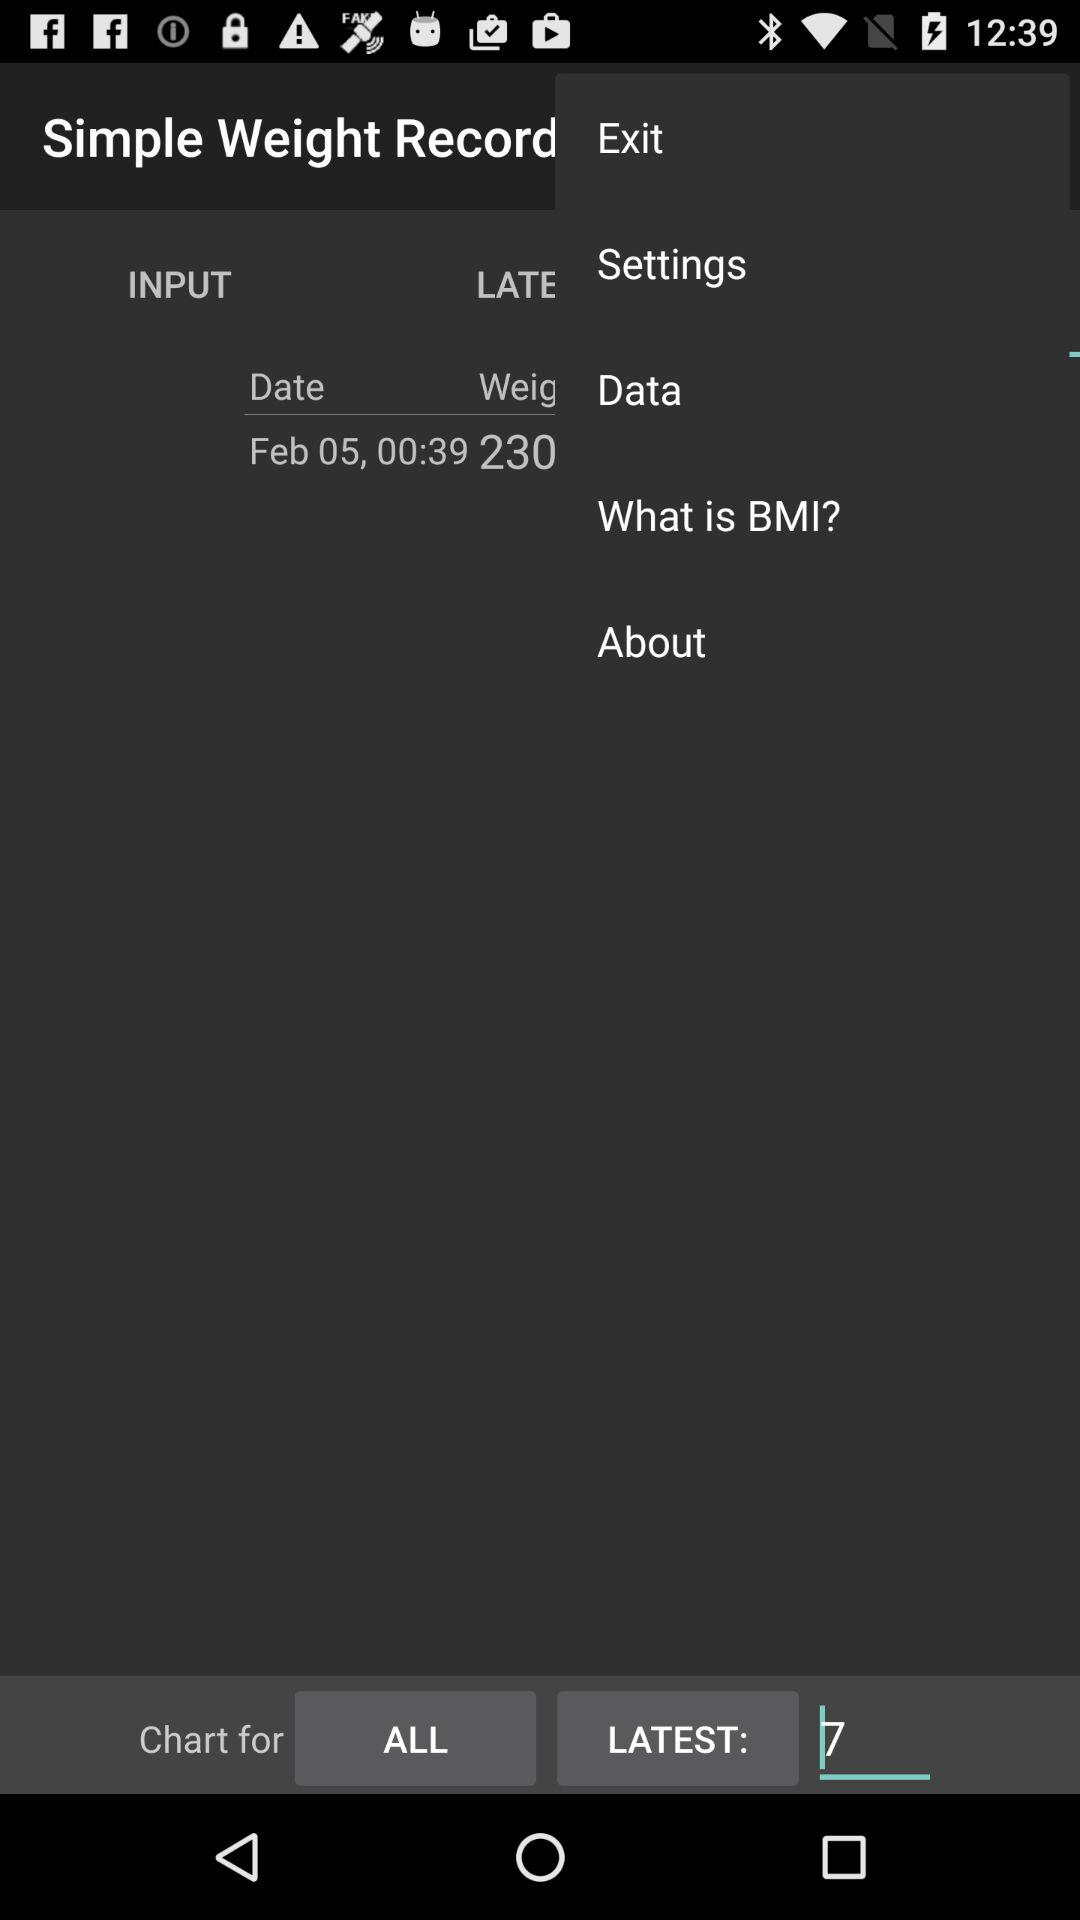What is the date? The date is February 05. 